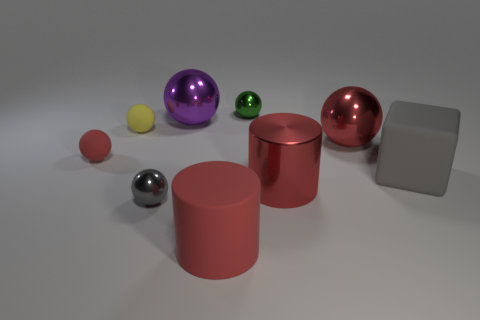Subtract all small green shiny balls. How many balls are left? 5 Subtract all red spheres. How many spheres are left? 4 Subtract all brown spheres. Subtract all red cubes. How many spheres are left? 6 Add 1 purple things. How many objects exist? 10 Subtract all spheres. How many objects are left? 3 Subtract 0 brown blocks. How many objects are left? 9 Subtract all gray spheres. Subtract all large rubber blocks. How many objects are left? 7 Add 5 tiny metallic balls. How many tiny metallic balls are left? 7 Add 4 large gray objects. How many large gray objects exist? 5 